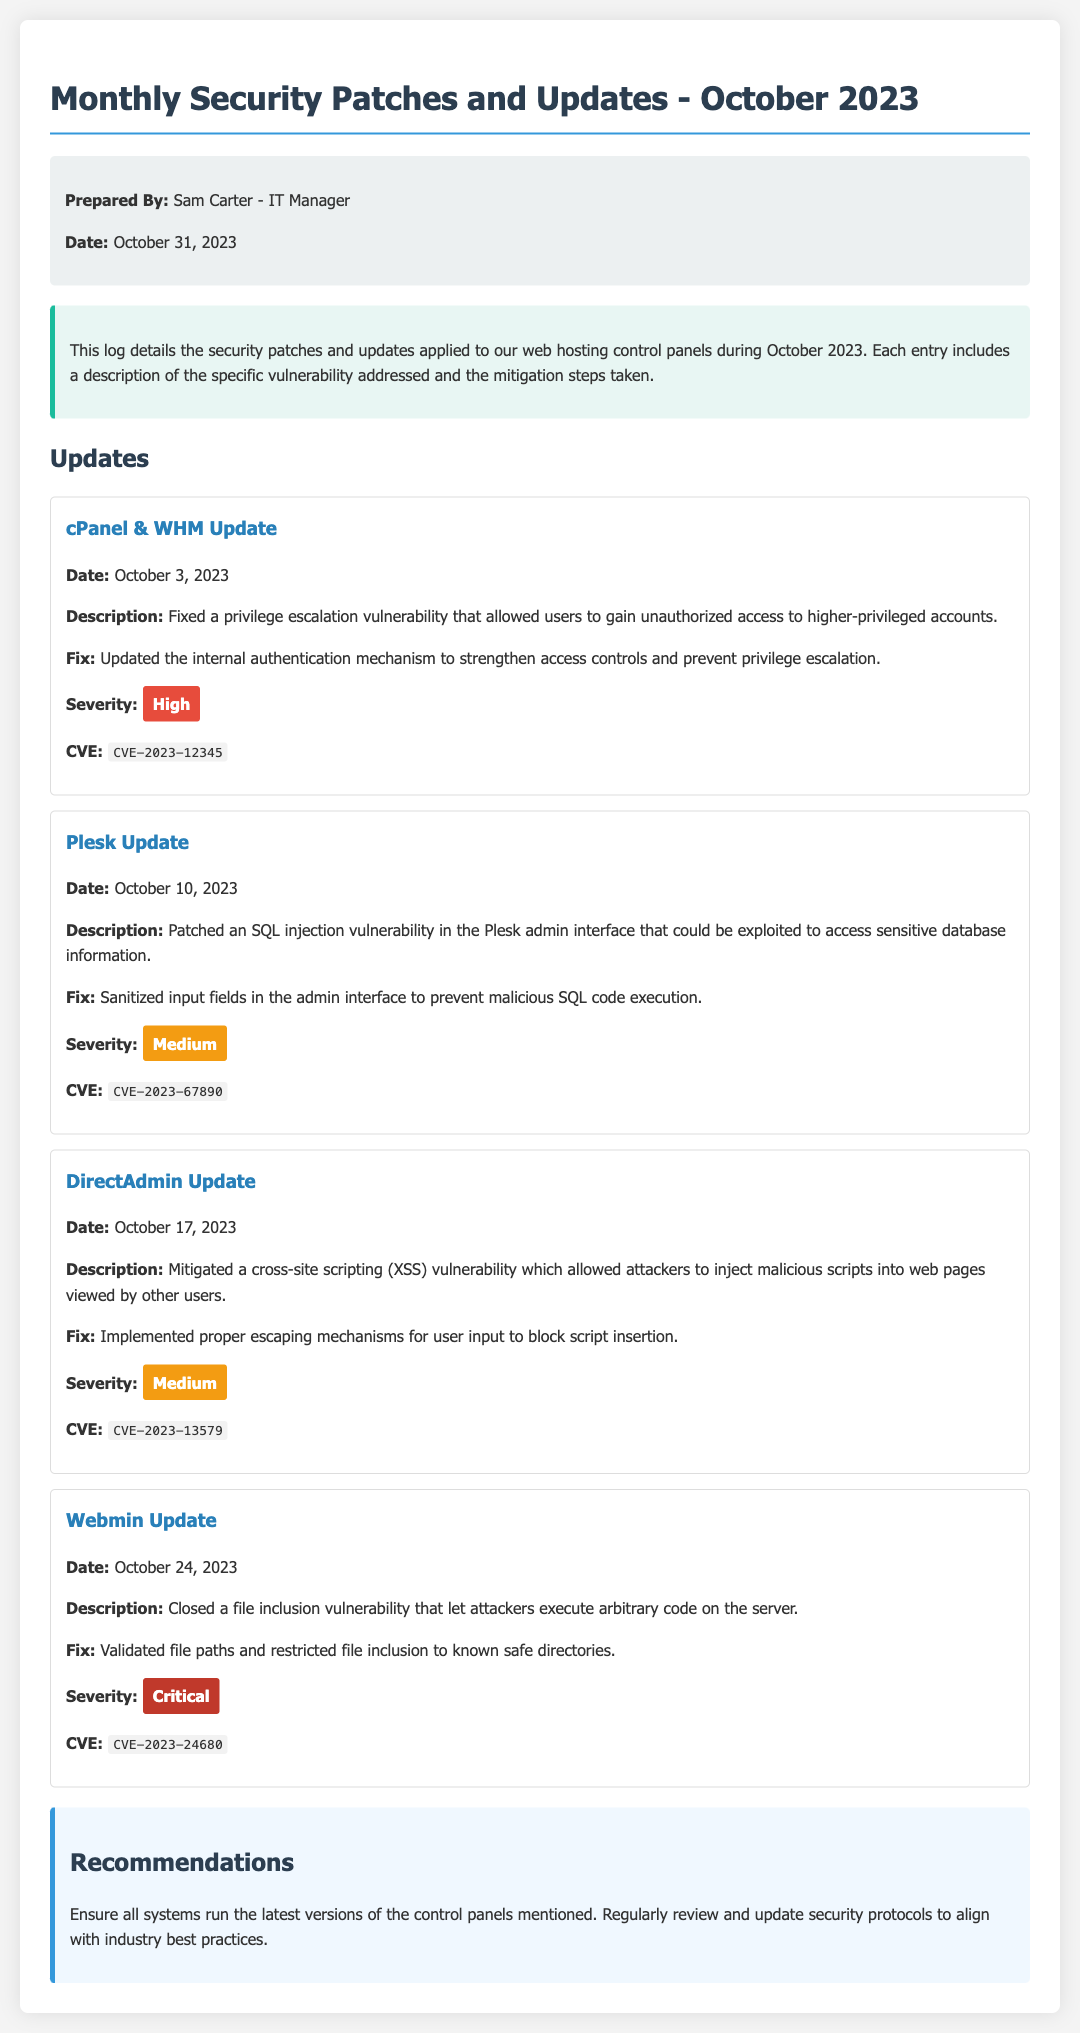What is the date of the cPanel & WHM update? The cPanel & WHM update was applied on October 3, 2023, as mentioned in the update section of the document.
Answer: October 3, 2023 What was the severity of the Webmin Update? The severity of the Webmin Update is classified as Critical, according to the severity label in the update section.
Answer: Critical How many updates were listed in the document? The document contains four updates, as outlined under the Updates section.
Answer: Four What kind of vulnerability was fixed in the Plesk Update? The Plesk Update fixed an SQL injection vulnerability, which is detailed in the description of that update.
Answer: SQL injection What recommendations are provided in the document? The recommendations suggest ensuring all systems run the latest versions of the control panels mentioned and regularly review security protocols.
Answer: Ensure all systems run the latest versions of the control panels mentioned Which control panel had a vulnerability related to privilege escalation? The control panel that had a vulnerability related to privilege escalation is cPanel & WHM, as described in its specific update entry.
Answer: cPanel & WHM What was the fix for the DirectAdmin Update? The fix for the DirectAdmin Update involved implementing proper escaping mechanisms for user input, which is explicitly stated in the document.
Answer: Implemented proper escaping mechanisms for user input What is the CVE identifier for the Webmin Update? The CVE identifier for the Webmin Update is CVE-2023-24680, as listed in the update details.
Answer: CVE-2023-24680 What was one of the specific actions taken in the cPanel & WHM fix? The specific action taken in the cPanel & WHM fix was updating the internal authentication mechanism.
Answer: Updated the internal authentication mechanism 